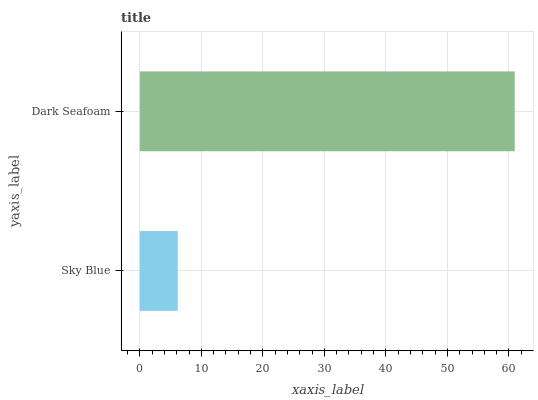Is Sky Blue the minimum?
Answer yes or no. Yes. Is Dark Seafoam the maximum?
Answer yes or no. Yes. Is Dark Seafoam the minimum?
Answer yes or no. No. Is Dark Seafoam greater than Sky Blue?
Answer yes or no. Yes. Is Sky Blue less than Dark Seafoam?
Answer yes or no. Yes. Is Sky Blue greater than Dark Seafoam?
Answer yes or no. No. Is Dark Seafoam less than Sky Blue?
Answer yes or no. No. Is Dark Seafoam the high median?
Answer yes or no. Yes. Is Sky Blue the low median?
Answer yes or no. Yes. Is Sky Blue the high median?
Answer yes or no. No. Is Dark Seafoam the low median?
Answer yes or no. No. 